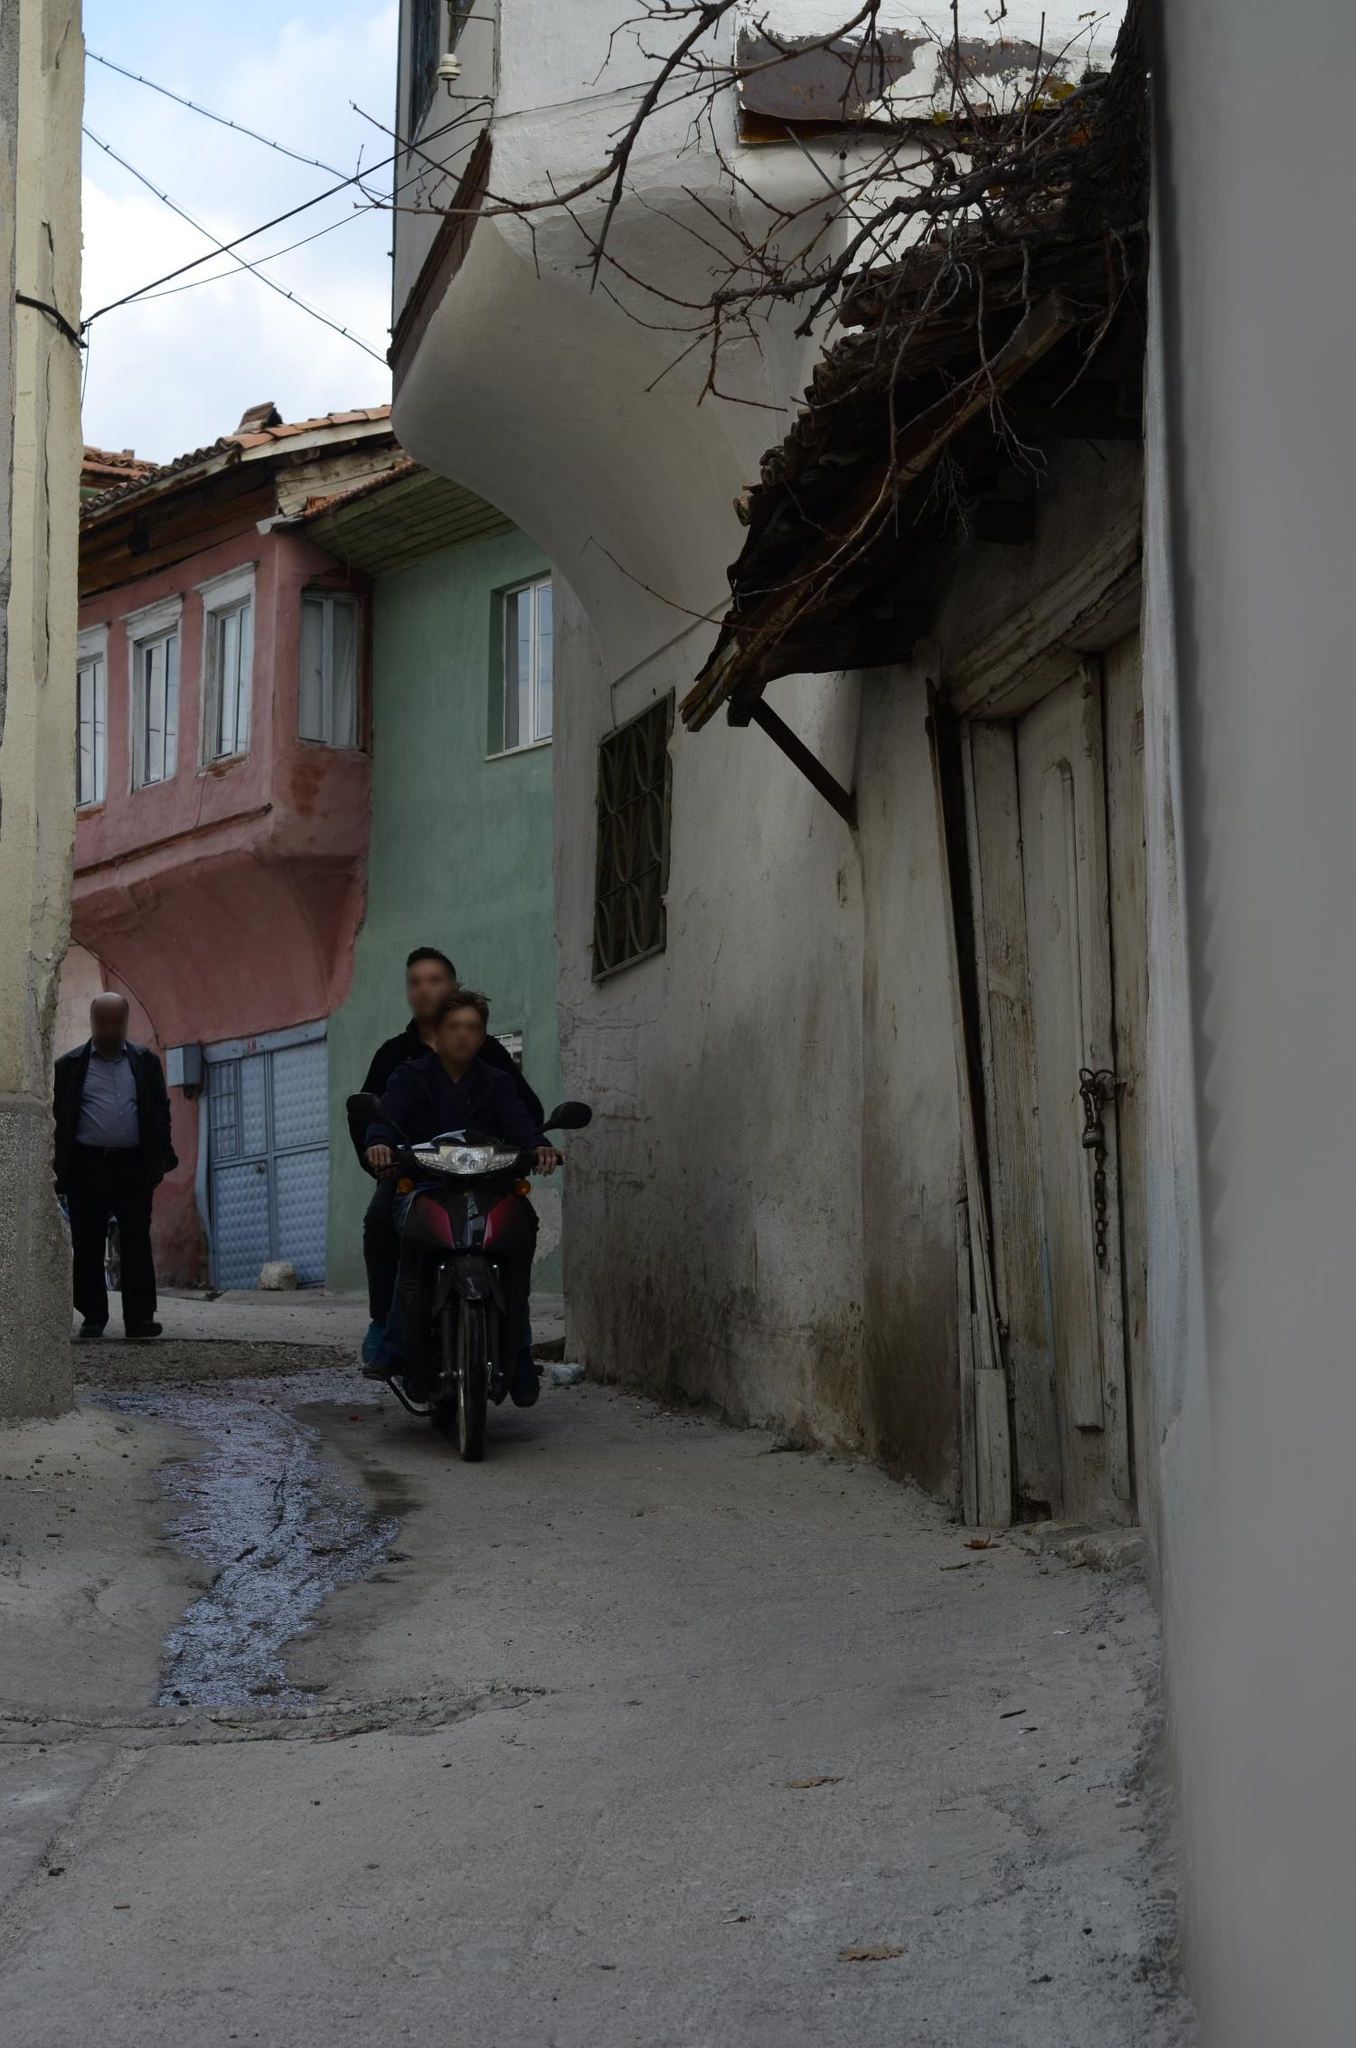What do you see happening in this image?
 The image captures a charming scene from a narrow street in a residential area. The street is lined with old houses, each bursting with its own unique color. The wooden doors and windows of the houses add a rustic touch to the vibrant scene. A man on a motorcycle is seen driving down the street, adding a dynamic element to the otherwise tranquil setting. Another man is walking on the sidewalk, perhaps a local resident or a visitor admiring the picturesque neighborhood. The perspective of the photo is particularly striking, taken from ground level and looking up, it offers a unique view of the houses against the backdrop of the sky. The image does not provide any specific details that could help identify the landmark "sa_14643". 